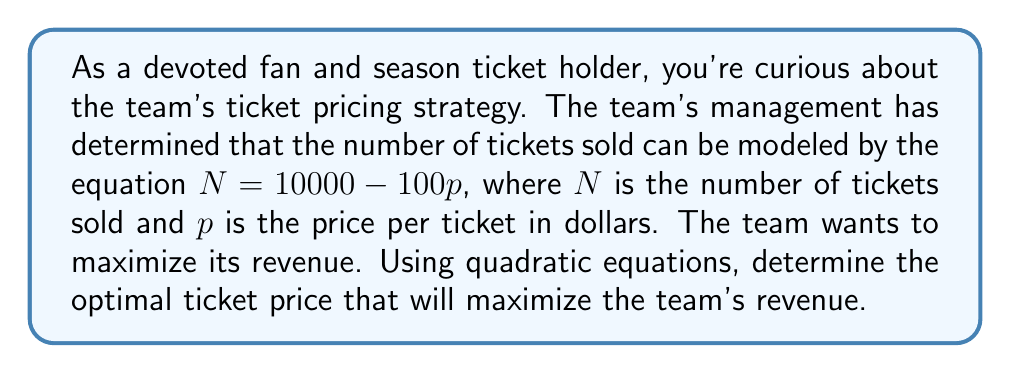Show me your answer to this math problem. Let's approach this step-by-step:

1) First, we need to set up the revenue function. Revenue is calculated by multiplying the number of tickets sold by the price per ticket:

   $R = pN$, where $R$ is revenue, $p$ is price, and $N$ is number of tickets sold.

2) We're given that $N = 10000 - 100p$. Let's substitute this into our revenue equation:

   $R = p(10000 - 100p)$

3) Expand this equation:

   $R = 10000p - 100p^2$

4) This is a quadratic function in the form $R = -100p^2 + 10000p$

5) To find the maximum value of a quadratic function, we can use the vertex formula. For a quadratic function in the form $ax^2 + bx + c$, the x-coordinate of the vertex is given by $x = -\frac{b}{2a}$

6) In our case, $a = -100$, $b = 10000$, and $c = 0$. Let's substitute these into the vertex formula:

   $p = -\frac{10000}{2(-100)} = \frac{10000}{200} = 50$

7) Therefore, the revenue is maximized when the price is $50.

8) We can verify this by testing values on either side of 50. For example, at $p = 49$ and $p = 51$, the revenue will be less than at $p = 50$.
Answer: The optimal ticket price to maximize revenue is $50 per ticket. 